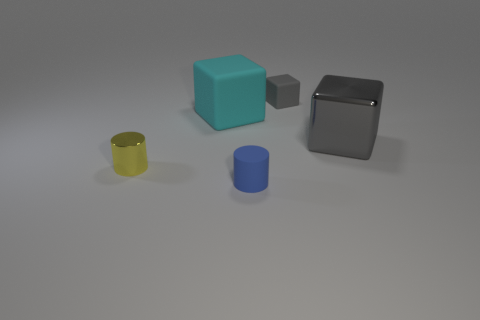There is another gray thing that is the same shape as the tiny gray thing; what is its material?
Your answer should be very brief. Metal. There is a tiny matte object that is behind the small blue matte object; is its color the same as the cube that is in front of the big cyan rubber object?
Ensure brevity in your answer.  Yes. What is the shape of the cyan thing?
Ensure brevity in your answer.  Cube. Are there more blue objects that are in front of the yellow cylinder than large brown metal things?
Keep it short and to the point. Yes. There is a metallic thing that is on the left side of the tiny gray cube; what shape is it?
Keep it short and to the point. Cylinder. How many other things are the same shape as the large gray thing?
Ensure brevity in your answer.  2. Are the gray thing that is to the right of the gray rubber block and the tiny yellow cylinder made of the same material?
Your answer should be compact. Yes. Are there the same number of tiny metallic cylinders that are on the right side of the small metal thing and cubes on the right side of the small blue object?
Your answer should be very brief. No. What size is the shiny object that is left of the big shiny thing?
Your response must be concise. Small. Is there a small gray thing made of the same material as the small blue cylinder?
Your response must be concise. Yes. 